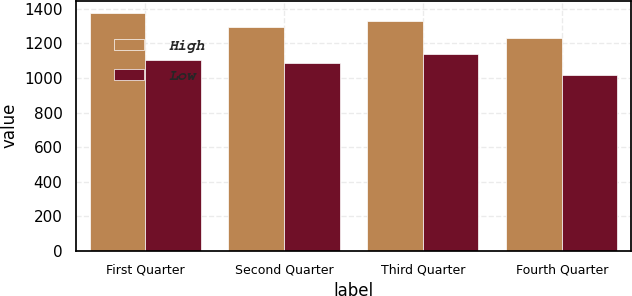Convert chart to OTSL. <chart><loc_0><loc_0><loc_500><loc_500><stacked_bar_chart><ecel><fcel>First Quarter<fcel>Second Quarter<fcel>Third Quarter<fcel>Fourth Quarter<nl><fcel>High<fcel>1378.96<fcel>1292.66<fcel>1329.9<fcel>1229<nl><fcel>Low<fcel>1103.9<fcel>1087.26<fcel>1139.27<fcel>1017.28<nl></chart> 